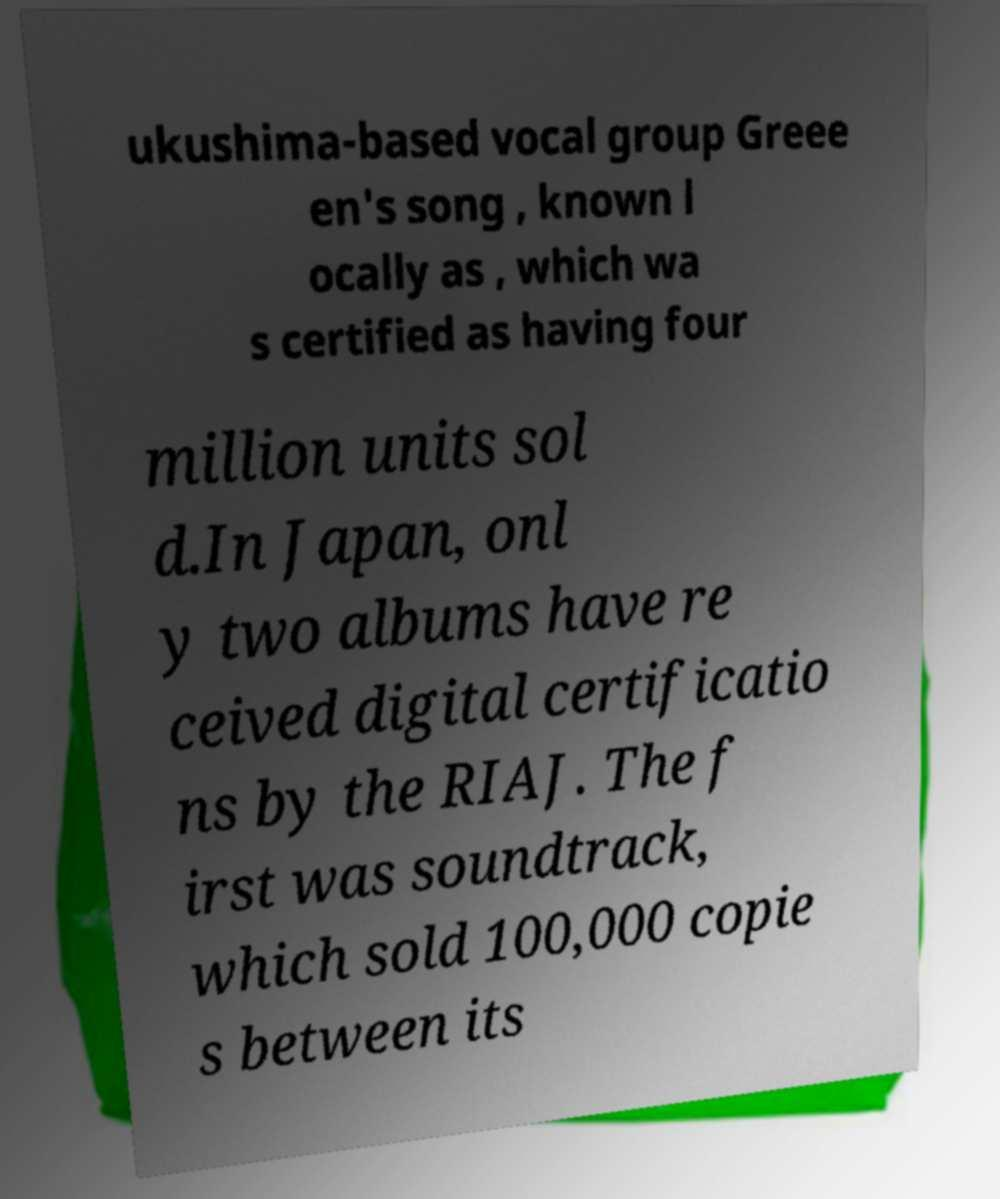There's text embedded in this image that I need extracted. Can you transcribe it verbatim? ukushima-based vocal group Greee en's song , known l ocally as , which wa s certified as having four million units sol d.In Japan, onl y two albums have re ceived digital certificatio ns by the RIAJ. The f irst was soundtrack, which sold 100,000 copie s between its 